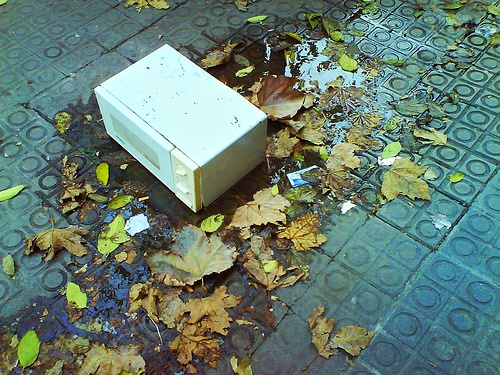Describe the objects in this image and their specific colors. I can see a microwave in lightgreen, lightblue, gray, and darkgreen tones in this image. 